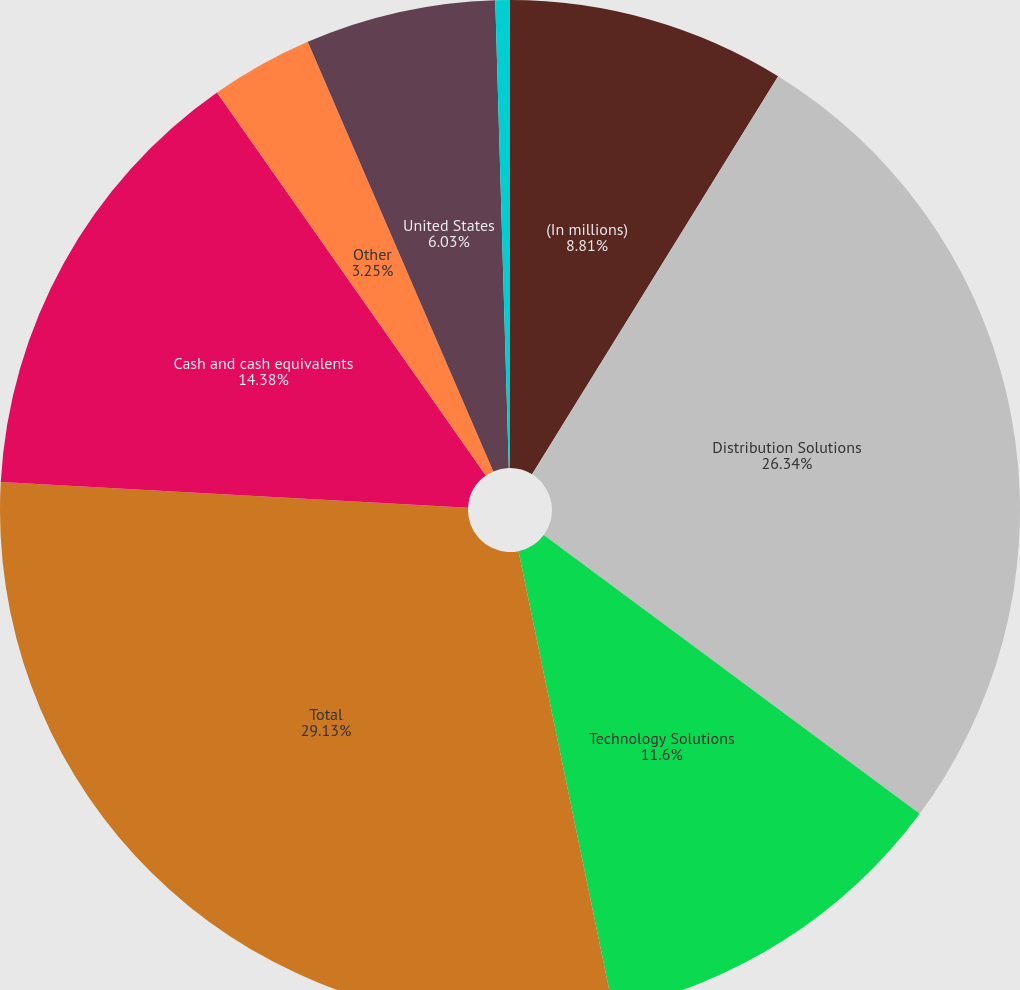Convert chart. <chart><loc_0><loc_0><loc_500><loc_500><pie_chart><fcel>(In millions)<fcel>Distribution Solutions<fcel>Technology Solutions<fcel>Total<fcel>Cash and cash equivalents<fcel>Other<fcel>United States<fcel>Foreign<nl><fcel>8.81%<fcel>26.34%<fcel>11.6%<fcel>29.12%<fcel>14.38%<fcel>3.25%<fcel>6.03%<fcel>0.46%<nl></chart> 